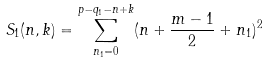<formula> <loc_0><loc_0><loc_500><loc_500>S _ { 1 } ( n , k ) = \sum _ { n _ { 1 } = 0 } ^ { p - q _ { 1 } - n + k } ( n + \frac { m - 1 } { 2 } + n _ { 1 } ) ^ { 2 }</formula> 